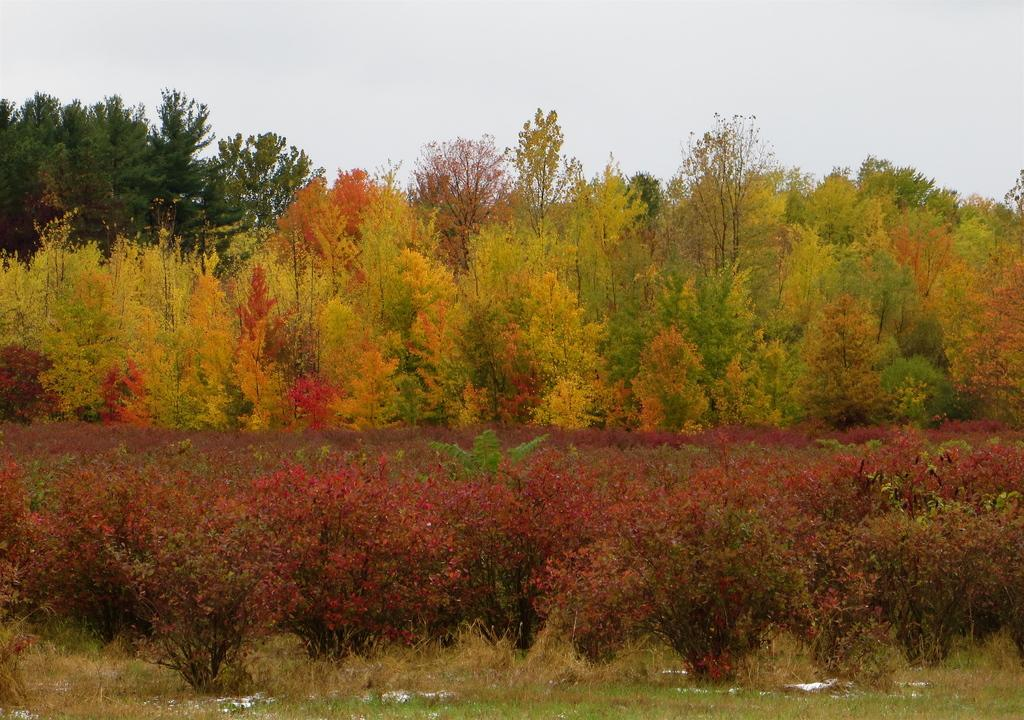What type of vegetation can be seen in the image? There are trees in the image. What is present at the bottom of the image? There is grass at the bottom of the image. What part of the natural environment is visible in the image? The sky is visible at the top of the image. What type of government is depicted in the image? A: There is no depiction of a government in the image; it features trees, grass, and the sky. What shape is the brass object in the image? There is no brass object present in the image. 